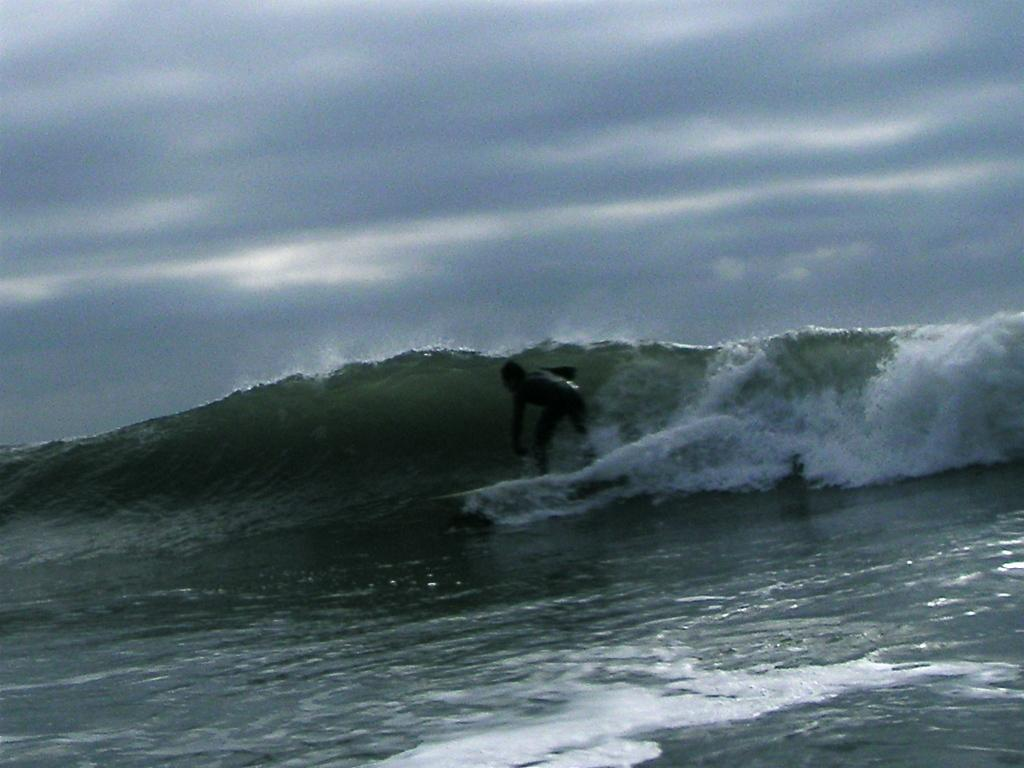What is the person in the image doing? The person is surfing on the water. What tool or equipment is the person using to surf? The person is using a surfboard. What can be seen in the background of the image? There is sky visible in the background of the image. What type of pancake is the person flipping in the image? There is no pancake present in the image; the person is surfing on the water using a surfboard. What is the person using to carry water in the image? There is no pail or any object used for carrying water present in the image. 